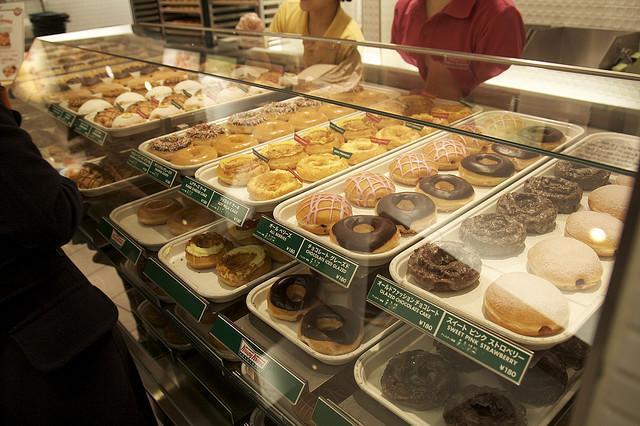How many employees are visible?
Give a very brief answer. 2. How many people are in the photo?
Give a very brief answer. 3. How many donuts are visible?
Give a very brief answer. 7. 